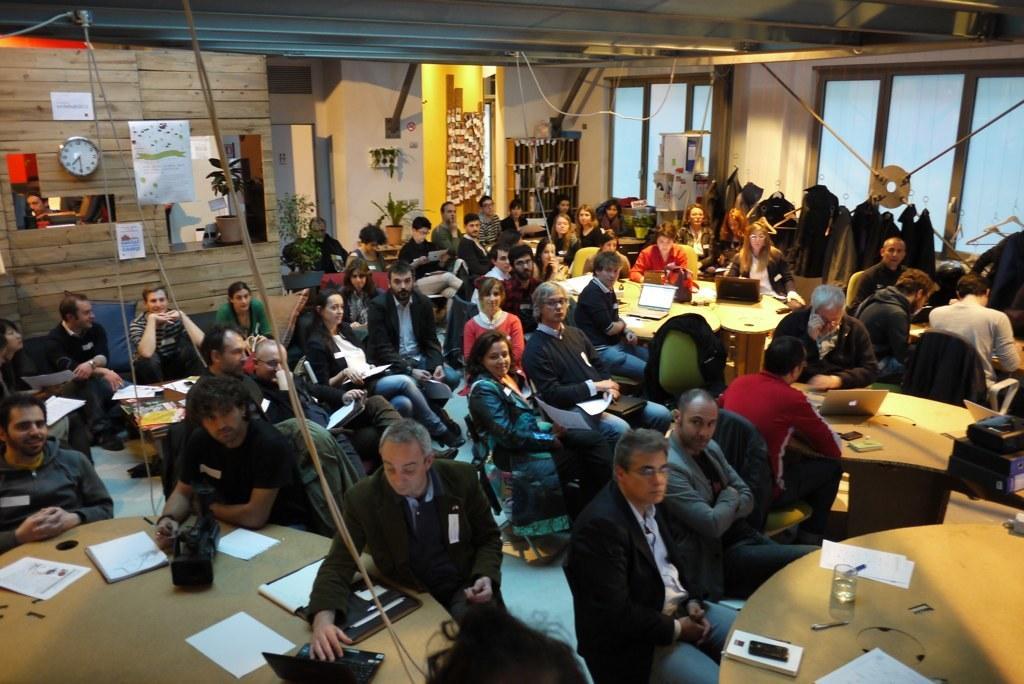How would you summarize this image in a sentence or two? In this image there are many people sitting around the table. This is wooden wall on which a wall clock is placed and few posters are also placed. In the background of the image there is a flower pot with plants. On the top of the table there is a laptop, few papers, water glass, a mobile phone, a book etc. These are the glass windows. 